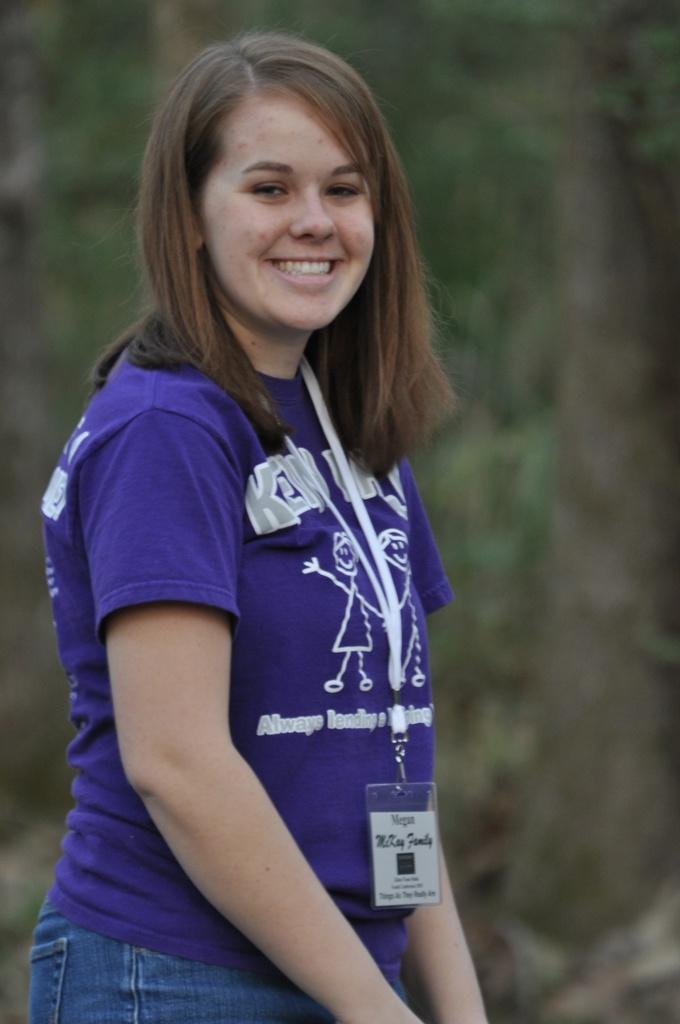Can you describe this image briefly? In the center of the image we can see a lady standing and smiling. In the background there are trees. 